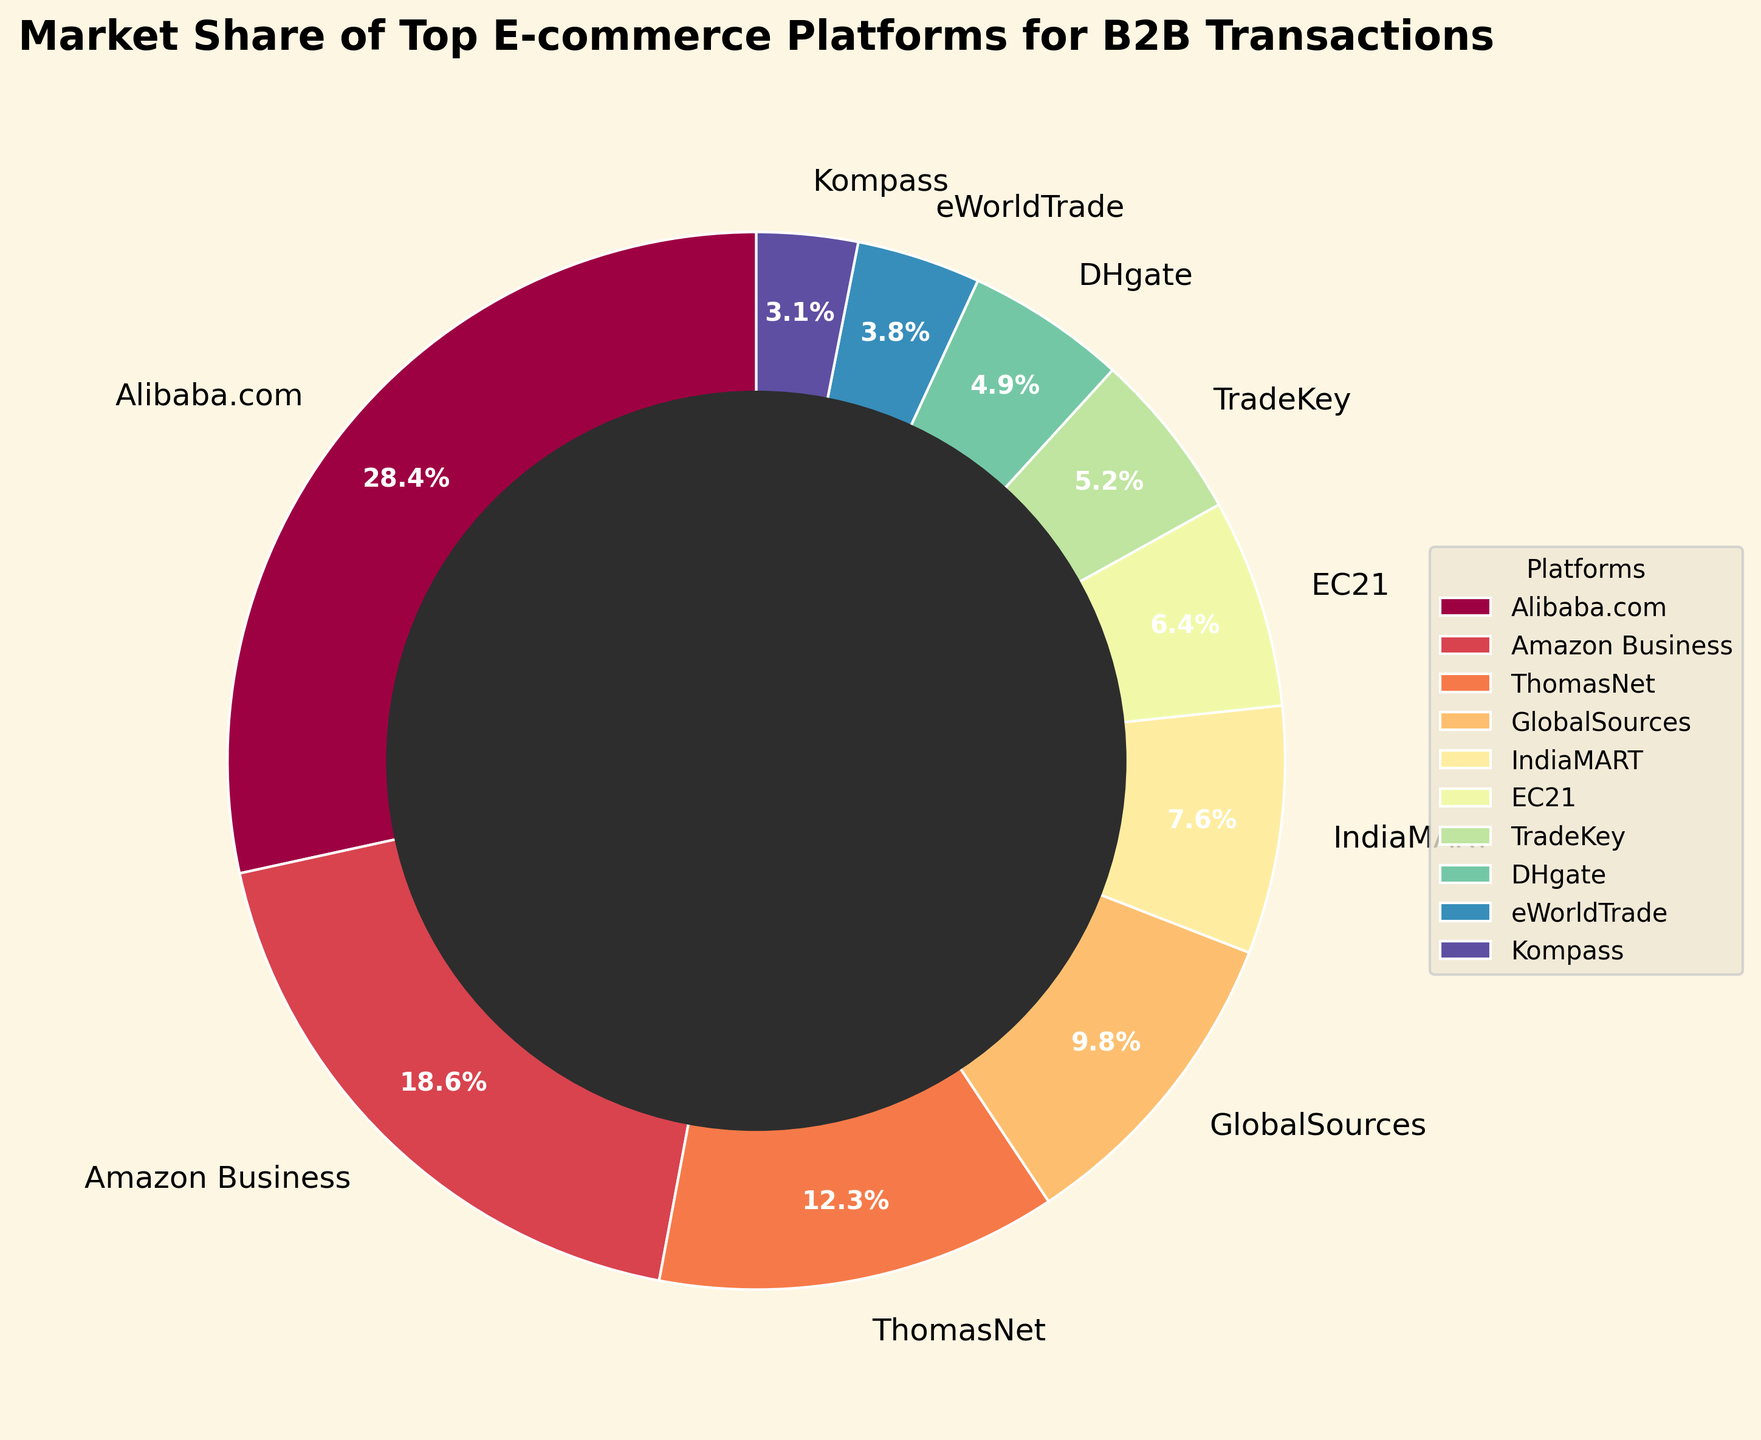What percentage of the market is held by platforms with less than 10% market share? To find this, add the market shares of all platforms that have less than 10%. These are: GlobalSources (9.8%), IndiaMART (7.6%), EC21 (6.4%), TradeKey (5.2%), DHgate (4.9%), eWorldTrade (3.8%), and Kompass (3.1%). Summing them: 9.8 + 7.6 + 6.4 + 5.2 + 4.9 + 3.8 + 3.1 = 40.8
Answer: 40.8% Which platform holds the largest market share? Identify the platform with the highest percentage. From the figure, Alibaba.com has the highest value of 28.5%.
Answer: Alibaba.com What is the difference in market share between the top two platforms? The top two platforms are Alibaba.com (28.5%) and Amazon Business (18.7%). Subtract the market share of Amazon Business from Alibaba.com: 28.5 - 18.7 = 9.8
Answer: 9.8% List the platforms in ascending order of their market share. Arrange the platforms based on their market share from lowest to highest. From the figure: Kompass (3.1%), eWorldTrade (3.8%), DHgate (4.9%), TradeKey (5.2%), EC21 (6.4%), IndiaMART (7.6%), GlobalSources (9.8%), ThomasNet (12.3%), Amazon Business (18.7%), Alibaba.com (28.5%)
Answer: Kompass, eWorldTrade, DHgate, TradeKey, EC21, IndiaMART, GlobalSources, ThomasNet, Amazon Business, Alibaba.com What is the combined market share of the three least popular platforms? Identify the three platforms with the smallest market shares and sum their values: Kompass (3.1%), eWorldTrade (3.8%), and DHgate (4.9%). Summing them: 3.1 + 3.8 + 4.9 = 11.8
Answer: 11.8% Which platform occupies the orange shaded segment in the pie chart? Observing the color shades in the pie chart, identify the segment marked by the orange color.
Answer: Varies with visualization (would need to see specific coloring) Is Amazon Business's market share more than double that of GlobalSources? Double the market share of GlobalSources (9.8%) is 2 * 9.8 = 19.6. Compare this with Amazon Business's share of 18.7%. Since 18.7 is less than 19.6, it is not more than double.
Answer: No What is the total market share for platforms that have more than 10% each? Identify platforms that have more than 10% market share: Alibaba.com (28.5%), Amazon Business (18.7%), ThomasNet (12.3%). Summing them: 28.5 + 18.7 + 12.3 = 59.5
Answer: 59.5% Which platform has a market share closest to the median market share value? Arrange the market shares in ascending order and identify the median (middle) value. From the data: 3.1, 3.8, 4.9, 5.2, 6.4, 7.6, 9.8, 12.3, 18.7, 28.5. The median value is the average of 6.4 and 7.6 which is (6.4+7.6)/2 = 7.0. IndiaMART, with a market share of 7.6%, is the closest to this median value.
Answer: IndiaMART Which platform's market share is closest in value to TradeKey's share? The market share for TradeKey is 5.2%. Look at the figures to identify the platform closest in value, which is DHgate with a market share of 4.9%.
Answer: DHgate 